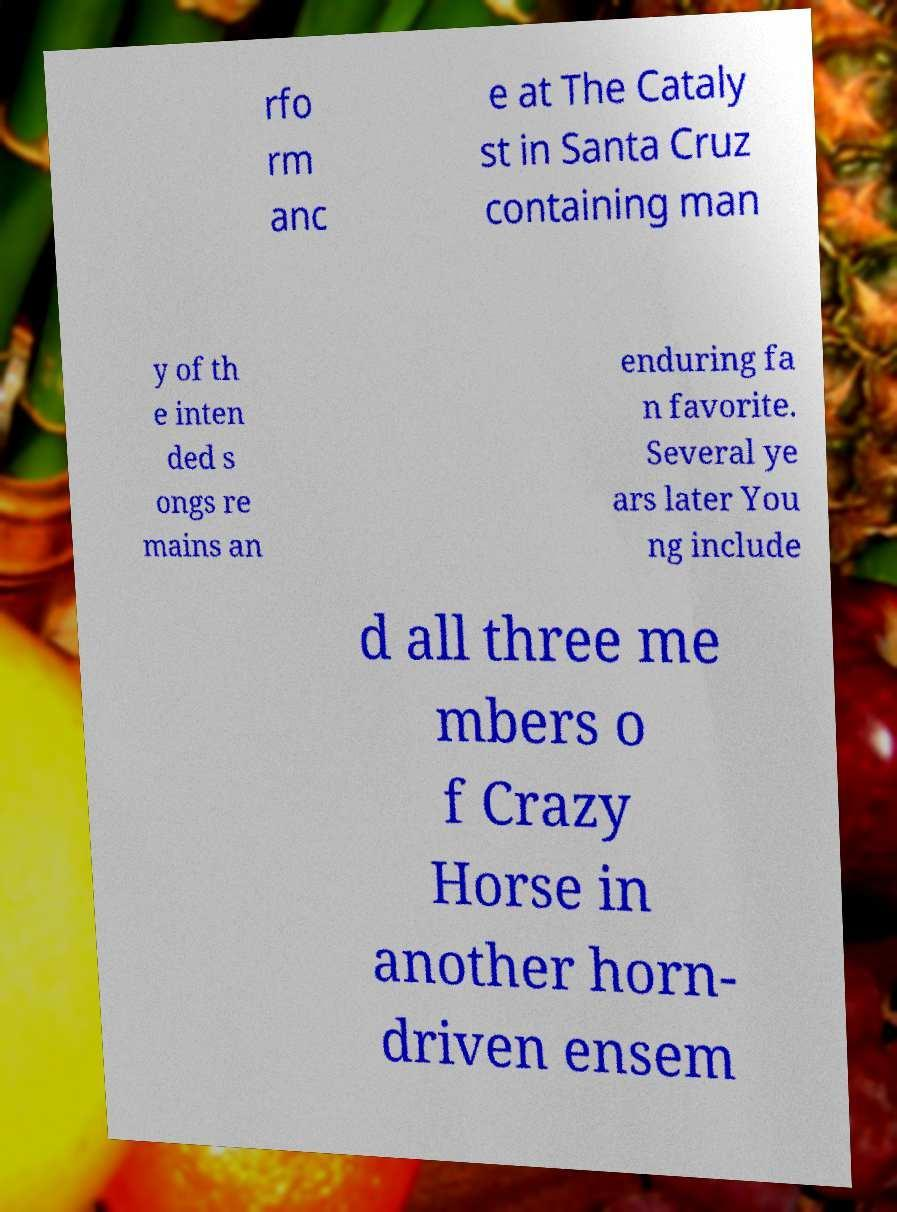Can you accurately transcribe the text from the provided image for me? rfo rm anc e at The Cataly st in Santa Cruz containing man y of th e inten ded s ongs re mains an enduring fa n favorite. Several ye ars later You ng include d all three me mbers o f Crazy Horse in another horn- driven ensem 